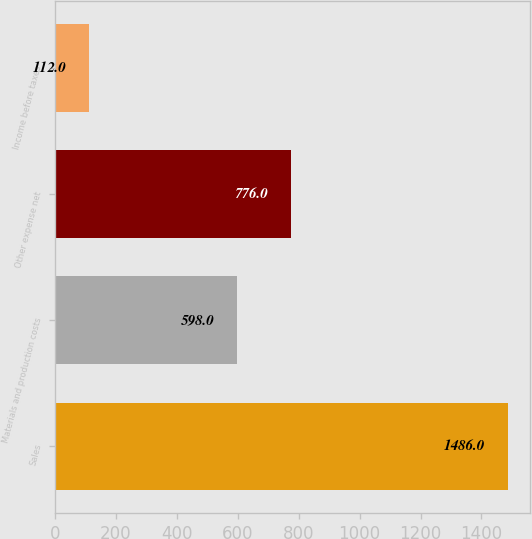<chart> <loc_0><loc_0><loc_500><loc_500><bar_chart><fcel>Sales<fcel>Materials and production costs<fcel>Other expense net<fcel>Income before taxes<nl><fcel>1486<fcel>598<fcel>776<fcel>112<nl></chart> 